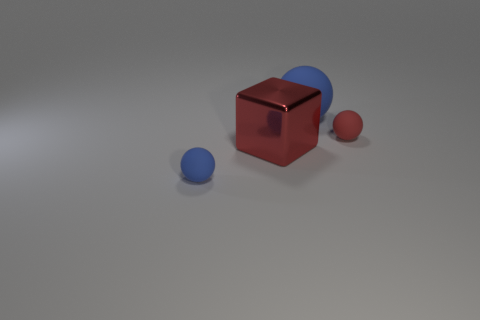Subtract all yellow cubes. How many blue balls are left? 2 Add 2 large metal balls. How many objects exist? 6 Subtract all big rubber spheres. How many spheres are left? 2 Subtract all cubes. How many objects are left? 3 Subtract 3 balls. How many balls are left? 0 Subtract all blue spheres. How many spheres are left? 1 Add 2 tiny objects. How many tiny objects exist? 4 Subtract 0 gray cubes. How many objects are left? 4 Subtract all brown cubes. Subtract all yellow cylinders. How many cubes are left? 1 Subtract all big blue objects. Subtract all large shiny cubes. How many objects are left? 2 